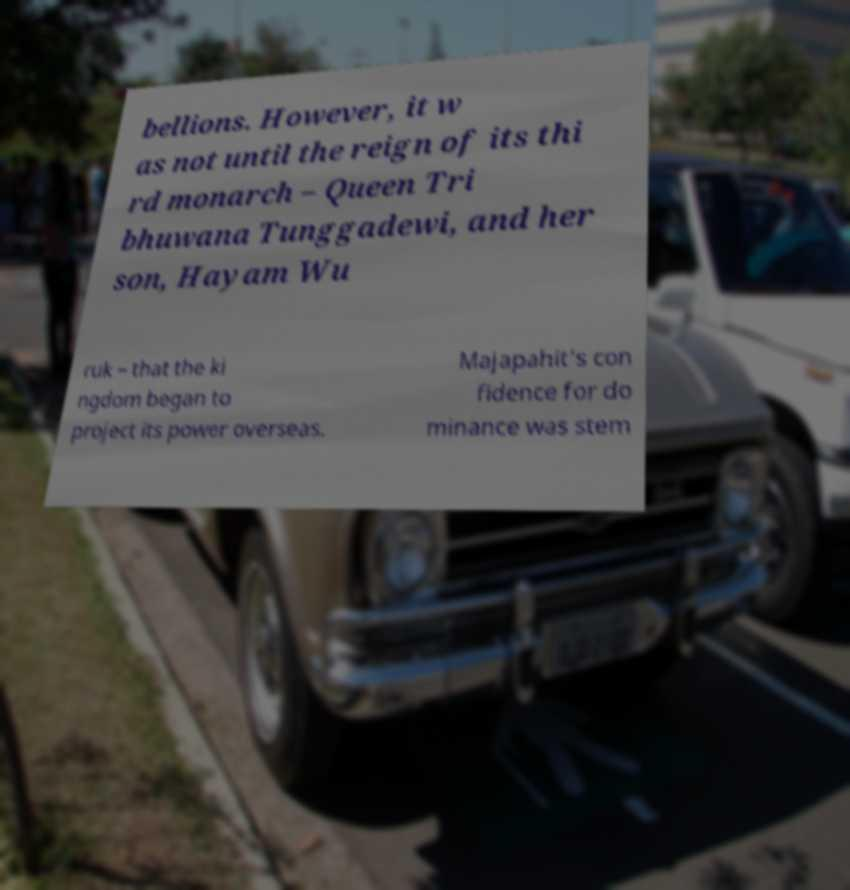Can you read and provide the text displayed in the image?This photo seems to have some interesting text. Can you extract and type it out for me? bellions. However, it w as not until the reign of its thi rd monarch – Queen Tri bhuwana Tunggadewi, and her son, Hayam Wu ruk – that the ki ngdom began to project its power overseas. Majapahit's con fidence for do minance was stem 